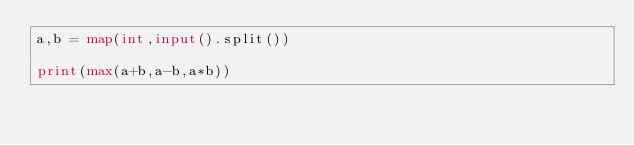<code> <loc_0><loc_0><loc_500><loc_500><_Python_>a,b = map(int,input().split())

print(max(a+b,a-b,a*b))</code> 